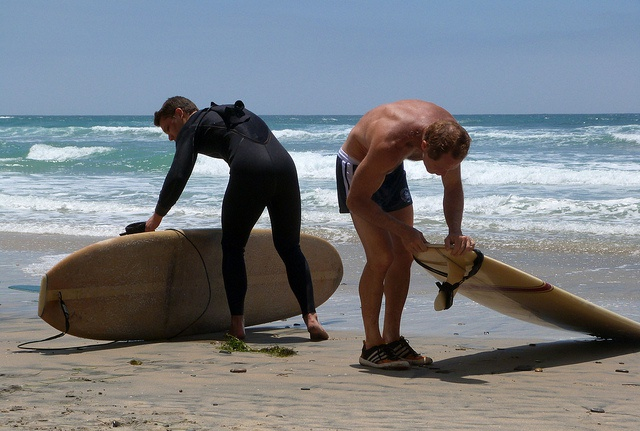Describe the objects in this image and their specific colors. I can see surfboard in darkgray, black, maroon, and gray tones, people in darkgray, black, maroon, and gray tones, people in darkgray, black, maroon, and gray tones, and surfboard in darkgray, black, maroon, and gray tones in this image. 